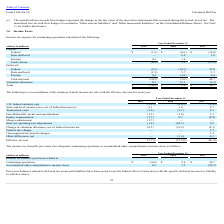According to Cincinnati Bell's financial document, What is the income tax (benefit) provision related to continuing operations in 2017? According to the financial document, $26.7 (in millions). The relevant text states: "Total $ (10.6) $ 9.4 $ 26.7..." Also, What is the income tax (benefit) provision related to continuing operations in 2018? According to the financial document, $9.4 (in millions). The relevant text states: "Total $ (10.6) $ 9.4 $ 26.7..." Also, What is the income tax (benefit) provision related to accumulated other comprehensive income in 2018? According to the financial document, 1.3 (in millions). The relevant text states: "Accumulated other comprehensive income (loss) 0.2 1.3 (28.3)..." Also, can you calculate: What is the income tax (benefit) provision related to continuing operations in 2017 and 2018? Based on the calculation: $26.7+$9.4, the result is 36.1 (in millions). This is based on the information: "Total $ (10.6) $ 9.4 $ 26.7 Total $ (10.6) $ 9.4 $ 26.7..." The key data points involved are: 26.7, 9.4. Also, can you calculate: What is the percentage change in income tax from accumulated other comprehensive income between 2018 and 2019? To answer this question, I need to perform calculations using the financial data. The calculation is: (0.2-1.3)/1.3, which equals -84.62 (percentage). This is based on the information: "Accumulated other comprehensive income (loss) 0.2 1.3 (28.3) Accumulated other comprehensive income (loss) 0.2 1.3 (28.3)..." The key data points involved are: 0.2, 1.3. Also, can you calculate: What is the total income tax provision relate to continuing operations between 2017 to 2019? Based on the calculation: $(10.6) +$9.4 +$26.7, the result is 25.5 (in millions). This is based on the information: "Total $ (10.6) $ 9.4 $ 26.7 Total $ (10.6) $ 9.4 $ 26.7 Total $ (10.6) $ 9.4 $ 26.7..." The key data points involved are: 10.6, 26.7, 9.4. 